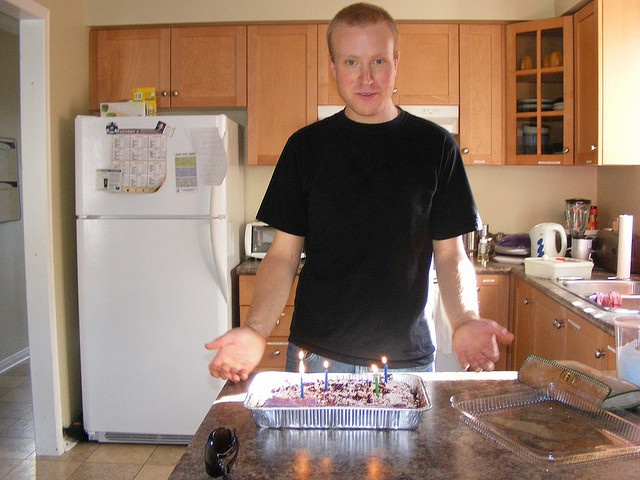Describe the objects in this image and their specific colors. I can see people in gray, black, salmon, and tan tones, refrigerator in gray, darkgray, and lightgray tones, dining table in gray, white, and darkgray tones, cake in gray, lightgray, darkgray, lightpink, and pink tones, and handbag in gray, brown, and tan tones in this image. 